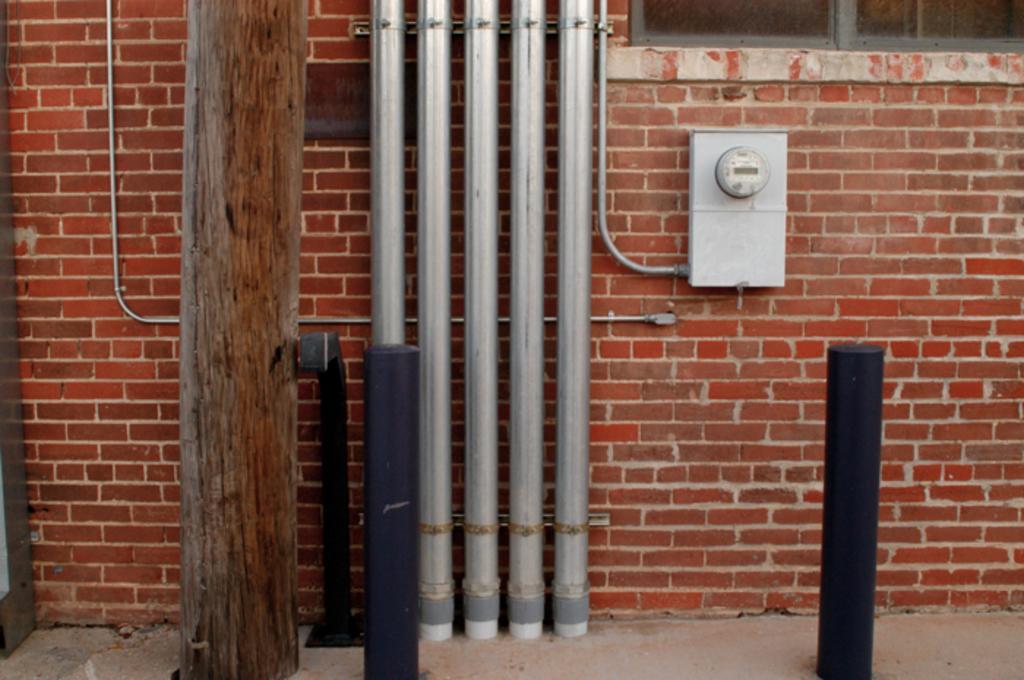Can you describe this image briefly? In the image there is a brick wall, in front of the wall there is a tree trunk, metal poles and other objects. 